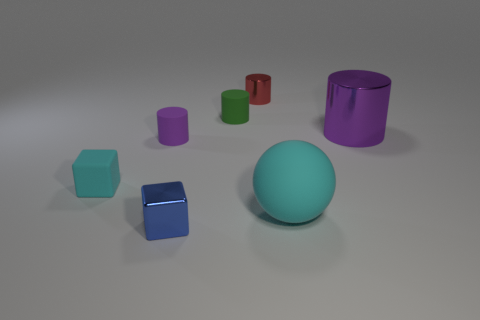Add 1 large green shiny balls. How many objects exist? 8 Subtract all balls. How many objects are left? 6 Add 2 green objects. How many green objects are left? 3 Add 6 purple objects. How many purple objects exist? 8 Subtract 0 green balls. How many objects are left? 7 Subtract all tiny green matte things. Subtract all big blue spheres. How many objects are left? 6 